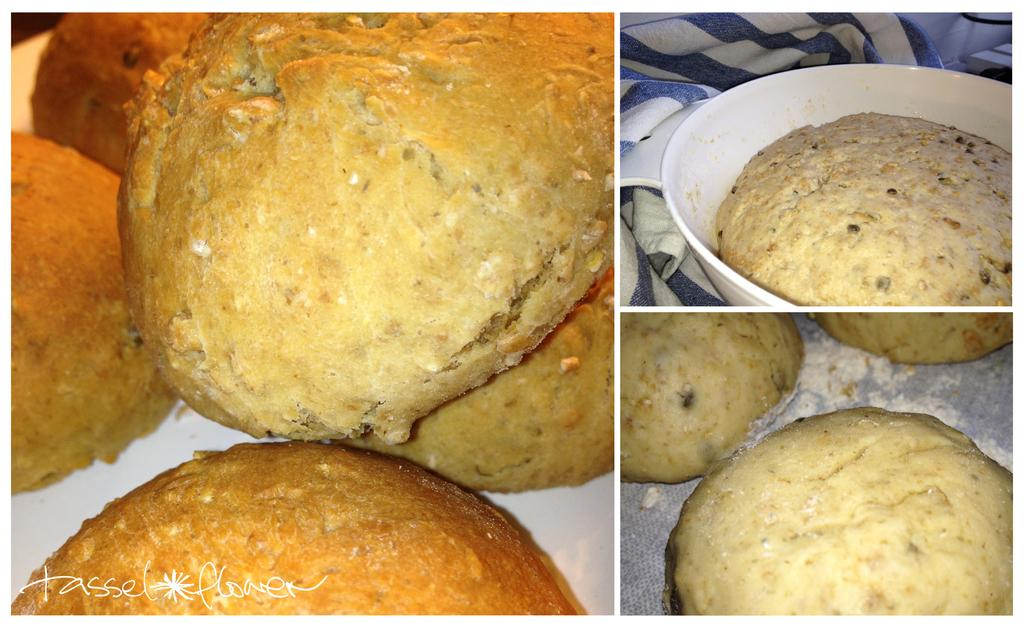How many images are combined to create the collage in the image? The image is a collage of three images. What type of food can be seen in the image? There are pancakes in the image. Where is the cloth located in the image? The cloth is located at the top right corner of the image. What type of bait is being used by the beast in the image? There is no beast or bait present in the image; it features a collage of three images, including pancakes and a cloth. 